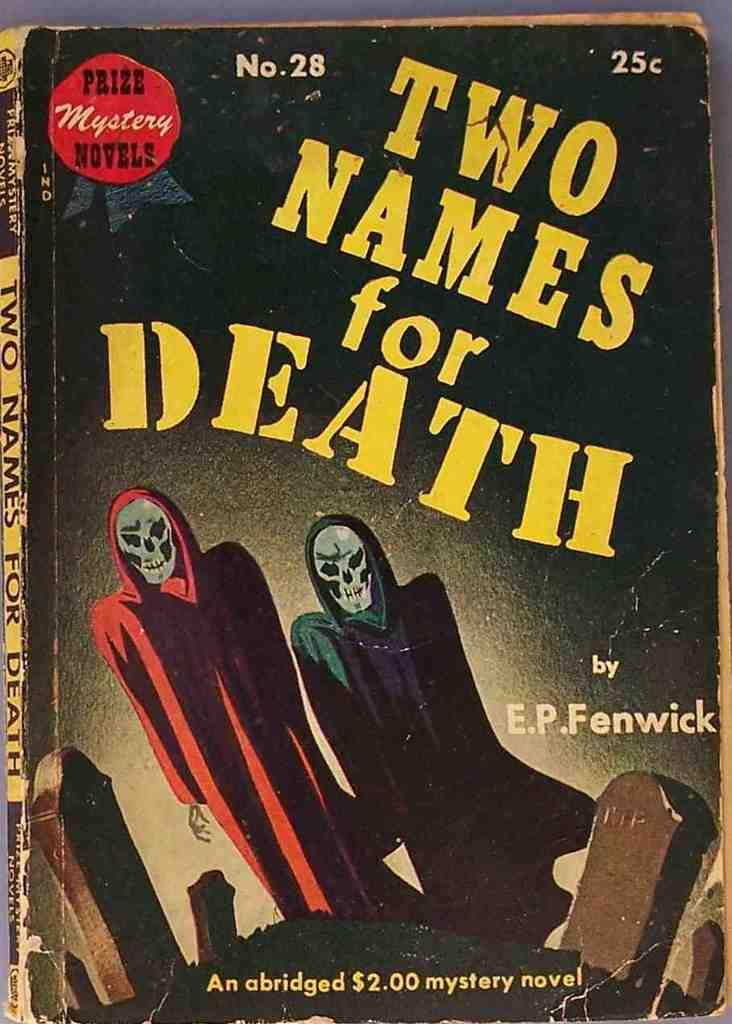<image>
Give a short and clear explanation of the subsequent image. A book numbered twenty eight has a twenty five cent price tag in the corner. 